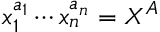<formula> <loc_0><loc_0><loc_500><loc_500>x _ { 1 } ^ { a _ { 1 } } \cdots x _ { n } ^ { a _ { n } } = X ^ { A }</formula> 